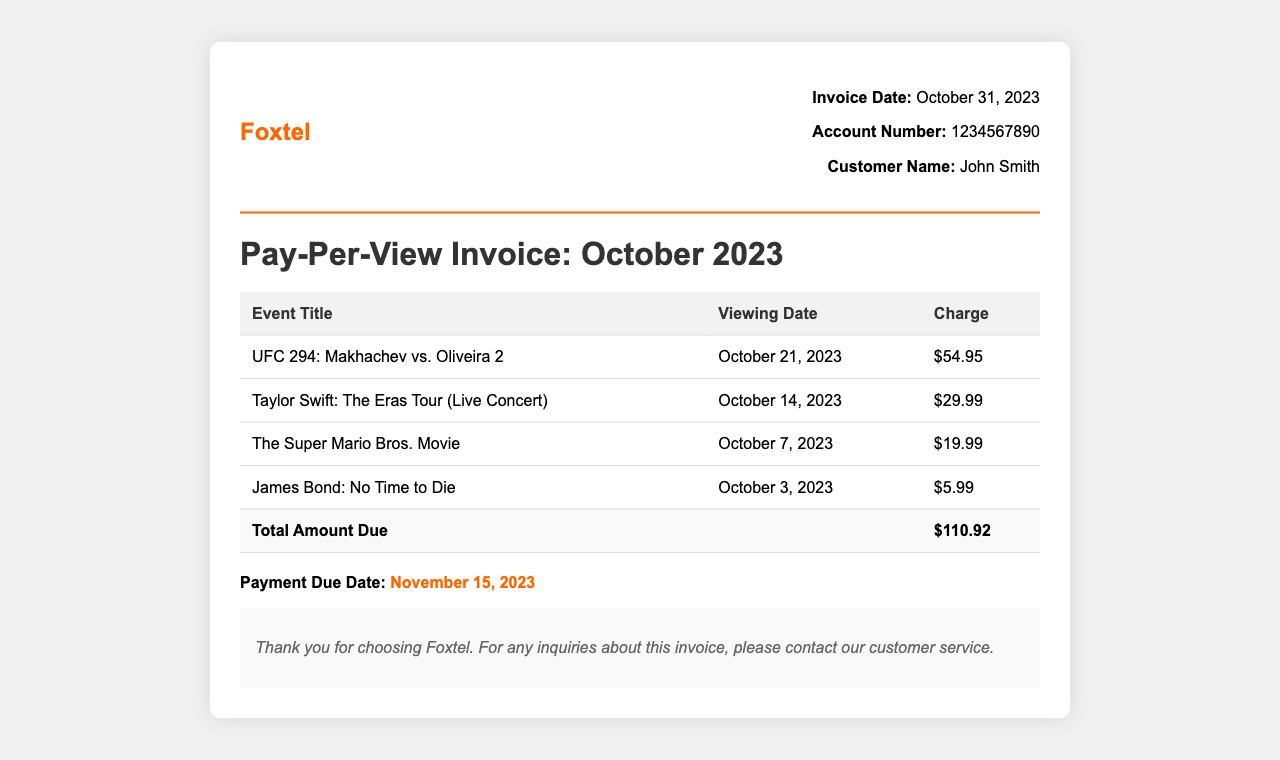What is the invoice date? The invoice date is clearly stated in the document as October 31, 2023.
Answer: October 31, 2023 Who is the customer? The document lists the customer name as John Smith.
Answer: John Smith What is the total amount due? The total amount due is calculated and shown at the bottom of the invoice as $110.92.
Answer: $110.92 When is the payment due date? The invoice specifies that the payment due date is November 15, 2023.
Answer: November 15, 2023 What was the charge for UFC 294? The document shows that the charge for UFC 294: Makhachev vs. Oliveira 2 is $54.95.
Answer: $54.95 On which date was The Super Mario Bros. Movie viewed? The viewing date for The Super Mario Bros. Movie is mentioned as October 7, 2023.
Answer: October 7, 2023 How many pay-per-view events were listed in the invoice? By counting the rows in the event list, we see there are four pay-per-view events listed.
Answer: Four What event was viewed on October 14, 2023? The document states that Taylor Swift: The Eras Tour (Live Concert) was viewed on October 14, 2023.
Answer: Taylor Swift: The Eras Tour (Live Concert) Is there a note about customer service in the document? The document includes a note thanking the customer and inviting them to contact customer service for inquiries.
Answer: Yes 